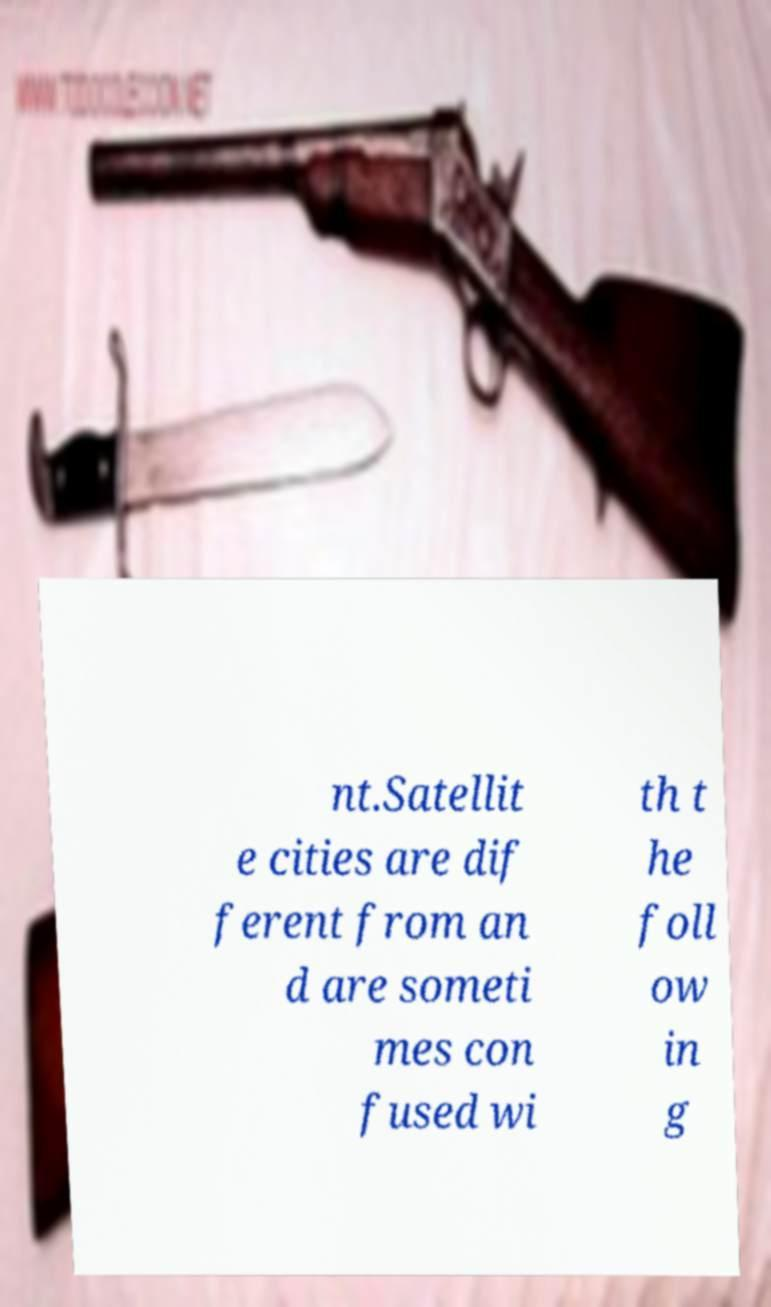Please read and relay the text visible in this image. What does it say? nt.Satellit e cities are dif ferent from an d are someti mes con fused wi th t he foll ow in g 